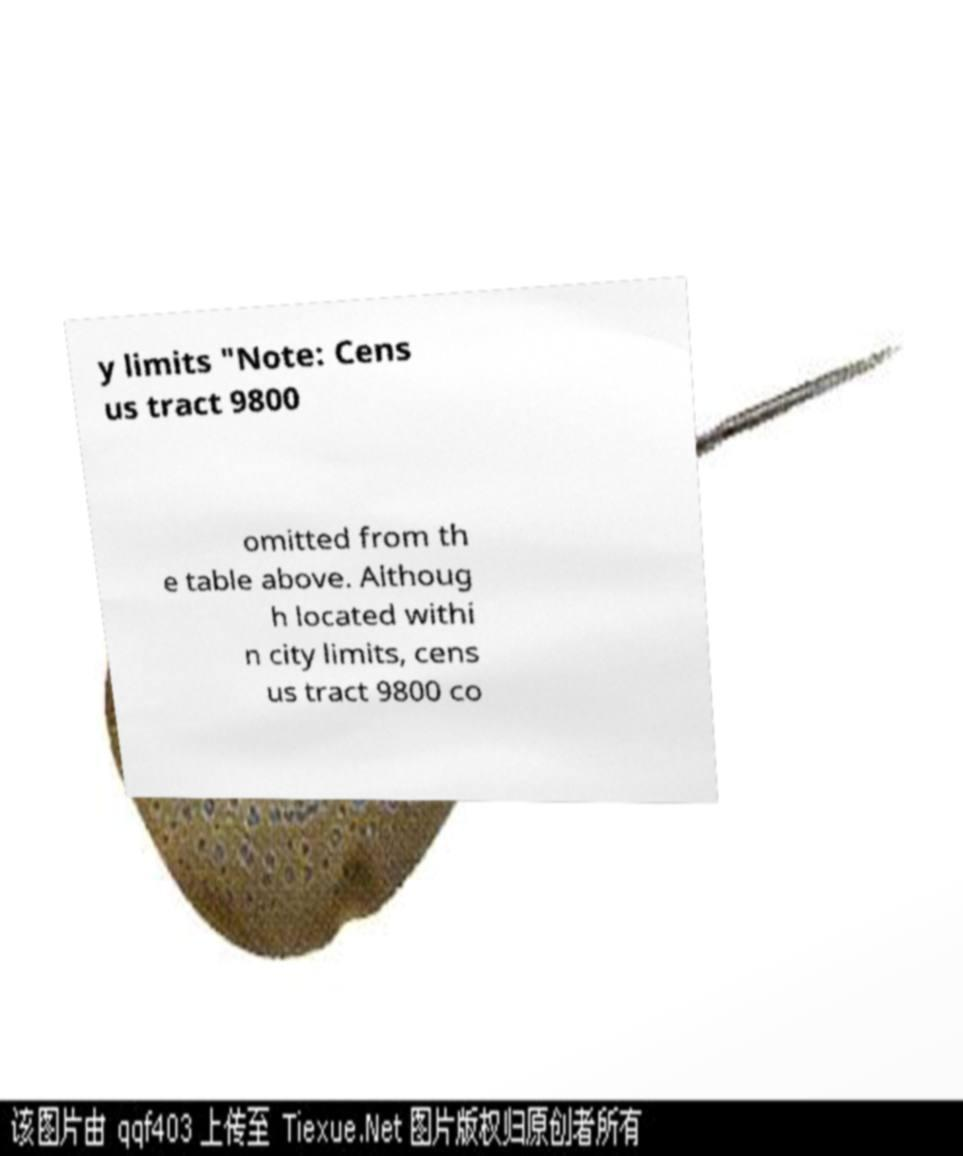Could you assist in decoding the text presented in this image and type it out clearly? y limits "Note: Cens us tract 9800 omitted from th e table above. Althoug h located withi n city limits, cens us tract 9800 co 